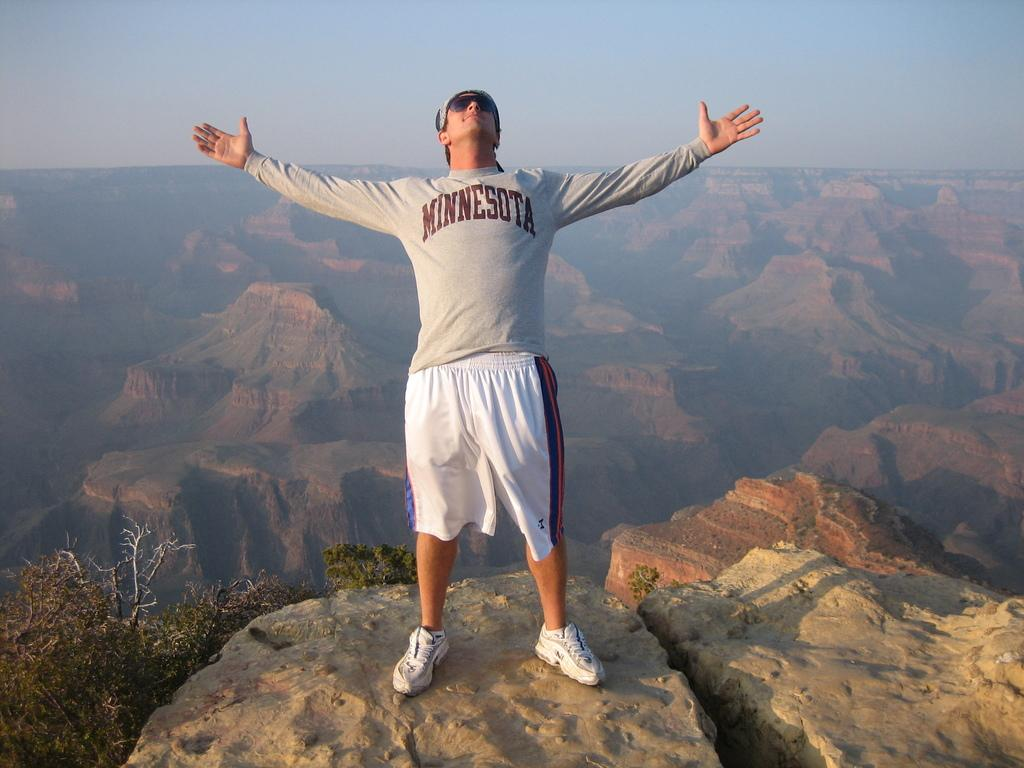What is the man in the image doing? The man is standing on a rock in the image. What type of vegetation can be seen in the image? There are trees in the image. What geographical feature is visible in the background of the image? There are mountains in the background of the image. What is visible at the top of the image? The sky is visible at the top of the image. Where is the faucet located in the image? There is no faucet present in the image. What causes the burst of colors in the image? The image does not depict a burst of colors; it is a natural scene with a man, trees, mountains, and sky. 